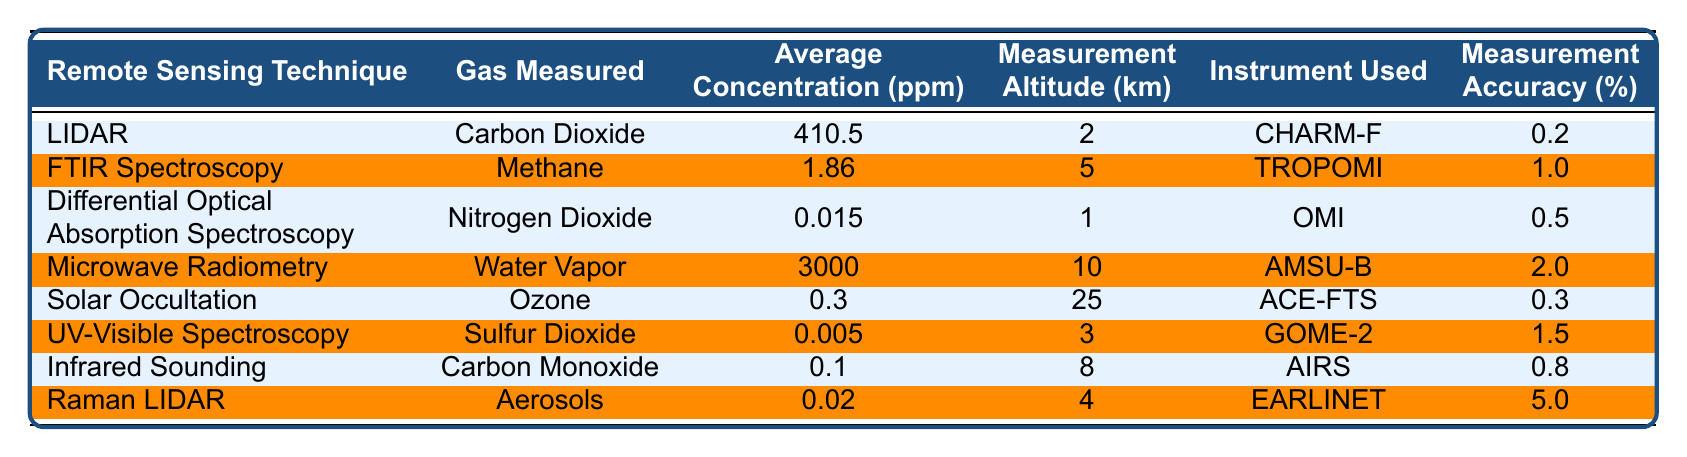What is the average concentration of Carbon Dioxide? The table lists the average concentration of Carbon Dioxide under the "Average Concentration (ppm)" column for LIDAR technique, which is 410.5 ppm.
Answer: 410.5 ppm Which gas has the highest measurement altitude? By checking the "Measurement Altitude (km)" column, Water Vapor measured by Microwave Radiometry has the highest altitude at 10 km.
Answer: Water Vapor What instrument is used to measure Ozone? The "Instrument Used" column indicates that Ozone is measured using the ACE-FTS instrument.
Answer: ACE-FTS Is the measurement accuracy for Methane greater than 1%? The "Measurement Accuracy (%)" for Methane is 1.0%, which is not greater than 1%.
Answer: No What is the total average concentration of Nitrogen Dioxide and Carbon Monoxide? The average concentration of Nitrogen Dioxide is 0.015 ppm and for Carbon Monoxide it is 0.1 ppm. Adding these gives a total of 0.015 + 0.1 = 0.115 ppm.
Answer: 0.115 ppm Which remote sensing technique measures the lowest concentration of gas? Looking at the "Average Concentration (ppm)" column, UV-Visible Spectroscopy measures 0.005 ppm, which is the lowest.
Answer: UV-Visible Spectroscopy What is the difference between the average concentration of Water Vapor and Carbon Dioxide? Water Vapor has an average concentration of 3000 ppm and Carbon Dioxide has 410.5 ppm. The difference is calculated as 3000 - 410.5 = 2589.5 ppm.
Answer: 2589.5 ppm What percent accuracy does Raman LIDAR provide? The "Measurement Accuracy (%)" for Raman LIDAR is provided directly in the table as 5.0%.
Answer: 5.0% Which gas is measured at the highest concentration and what is that concentration? The table shows that Water Vapor is measured at the highest concentration of 3000 ppm, which is noted in the "Average Concentration (ppm)" column.
Answer: Water Vapor at 3000 ppm Count how many techniques measure gases at altitudes greater than 5 km. Reviewing the "Measurement Altitude (km)" column, both Microwave Radiometry (10 km) and Solar Occultation (25 km) measure above 5 km. Therefore, there are 2 techniques.
Answer: 2 